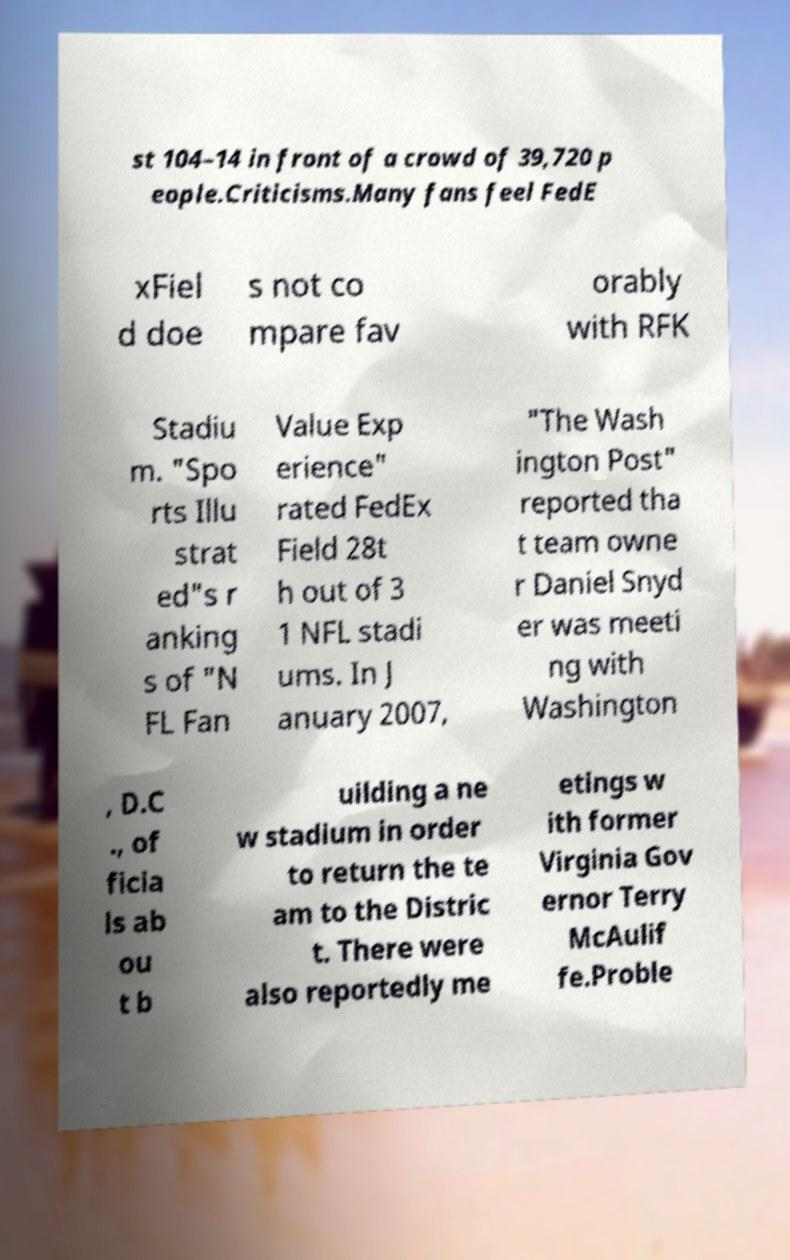Could you assist in decoding the text presented in this image and type it out clearly? st 104–14 in front of a crowd of 39,720 p eople.Criticisms.Many fans feel FedE xFiel d doe s not co mpare fav orably with RFK Stadiu m. "Spo rts Illu strat ed"s r anking s of "N FL Fan Value Exp erience" rated FedEx Field 28t h out of 3 1 NFL stadi ums. In J anuary 2007, "The Wash ington Post" reported tha t team owne r Daniel Snyd er was meeti ng with Washington , D.C ., of ficia ls ab ou t b uilding a ne w stadium in order to return the te am to the Distric t. There were also reportedly me etings w ith former Virginia Gov ernor Terry McAulif fe.Proble 